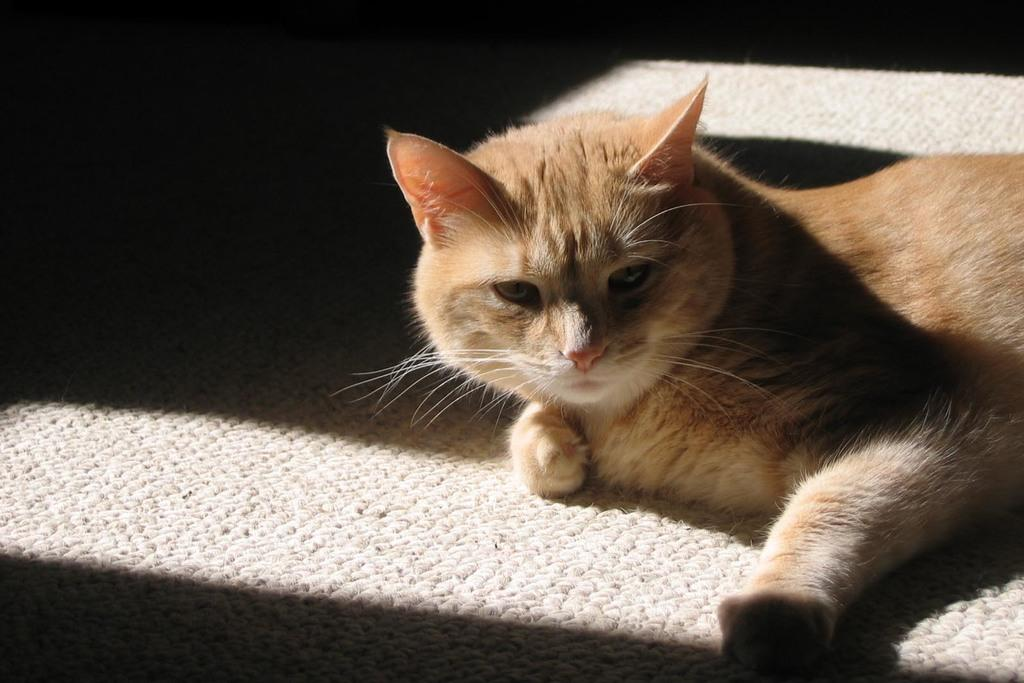What animal is present in the picture? There is a cat in the picture. What position is the cat in? The cat is lying on the floor. What color is the cat's fur? The cat has brown fur. What type of flooring is visible in the picture? There is a carpet on the floor. How many sheep are visible in the picture? There are no sheep present in the picture; it features a cat lying on a carpeted floor. 